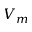<formula> <loc_0><loc_0><loc_500><loc_500>V _ { m }</formula> 